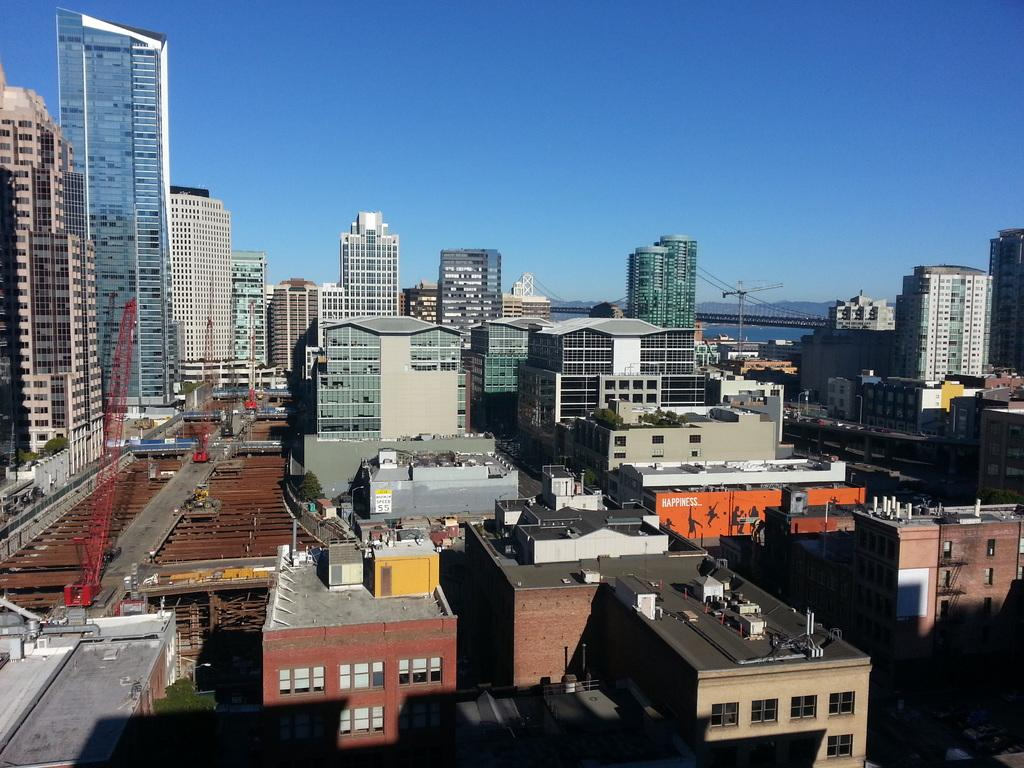What type of structures can be seen in the image? There are many buildings in the image. What natural feature is visible in the background of the image? There is a mountain visible in the background of the image. What type of bells are ringing in the image? There are no bells present in the image. What role does the actor play in the image? There is no actor present in the image. 